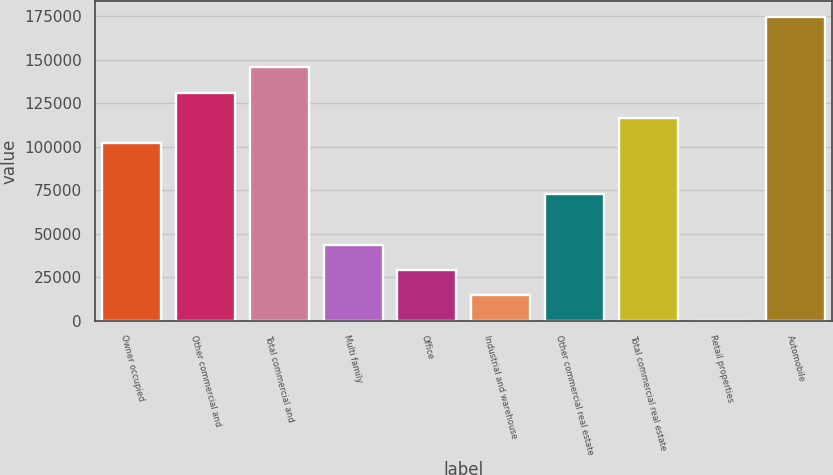Convert chart. <chart><loc_0><loc_0><loc_500><loc_500><bar_chart><fcel>Owner occupied<fcel>Other commercial and<fcel>Total commercial and<fcel>Multi family<fcel>Office<fcel>Industrial and warehouse<fcel>Other commercial real estate<fcel>Total commercial real estate<fcel>Retail properties<fcel>Automobile<nl><fcel>101908<fcel>131023<fcel>145581<fcel>43677.8<fcel>29120.2<fcel>14562.6<fcel>72793<fcel>116466<fcel>5<fcel>174696<nl></chart> 